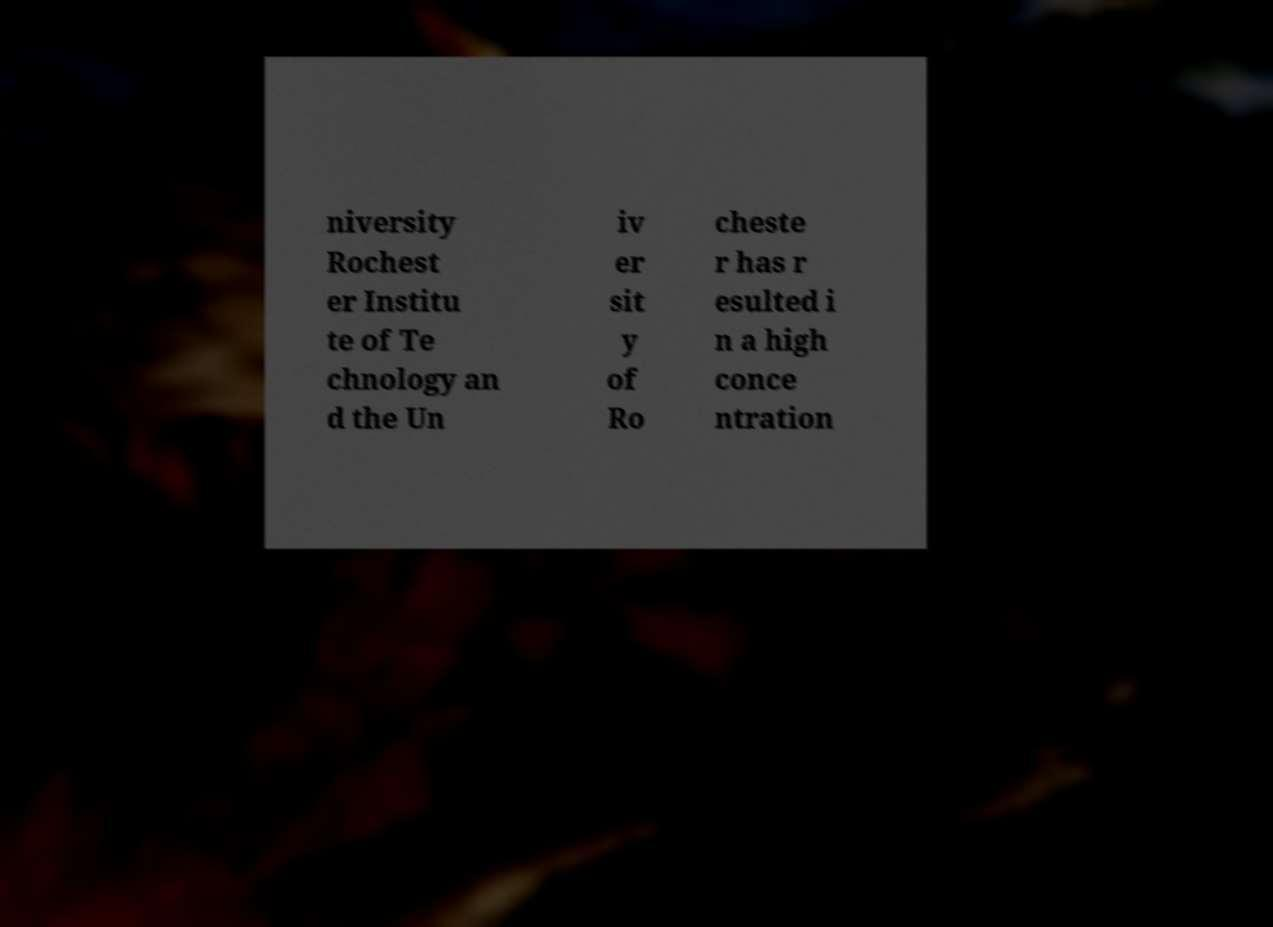What messages or text are displayed in this image? I need them in a readable, typed format. niversity Rochest er Institu te of Te chnology an d the Un iv er sit y of Ro cheste r has r esulted i n a high conce ntration 